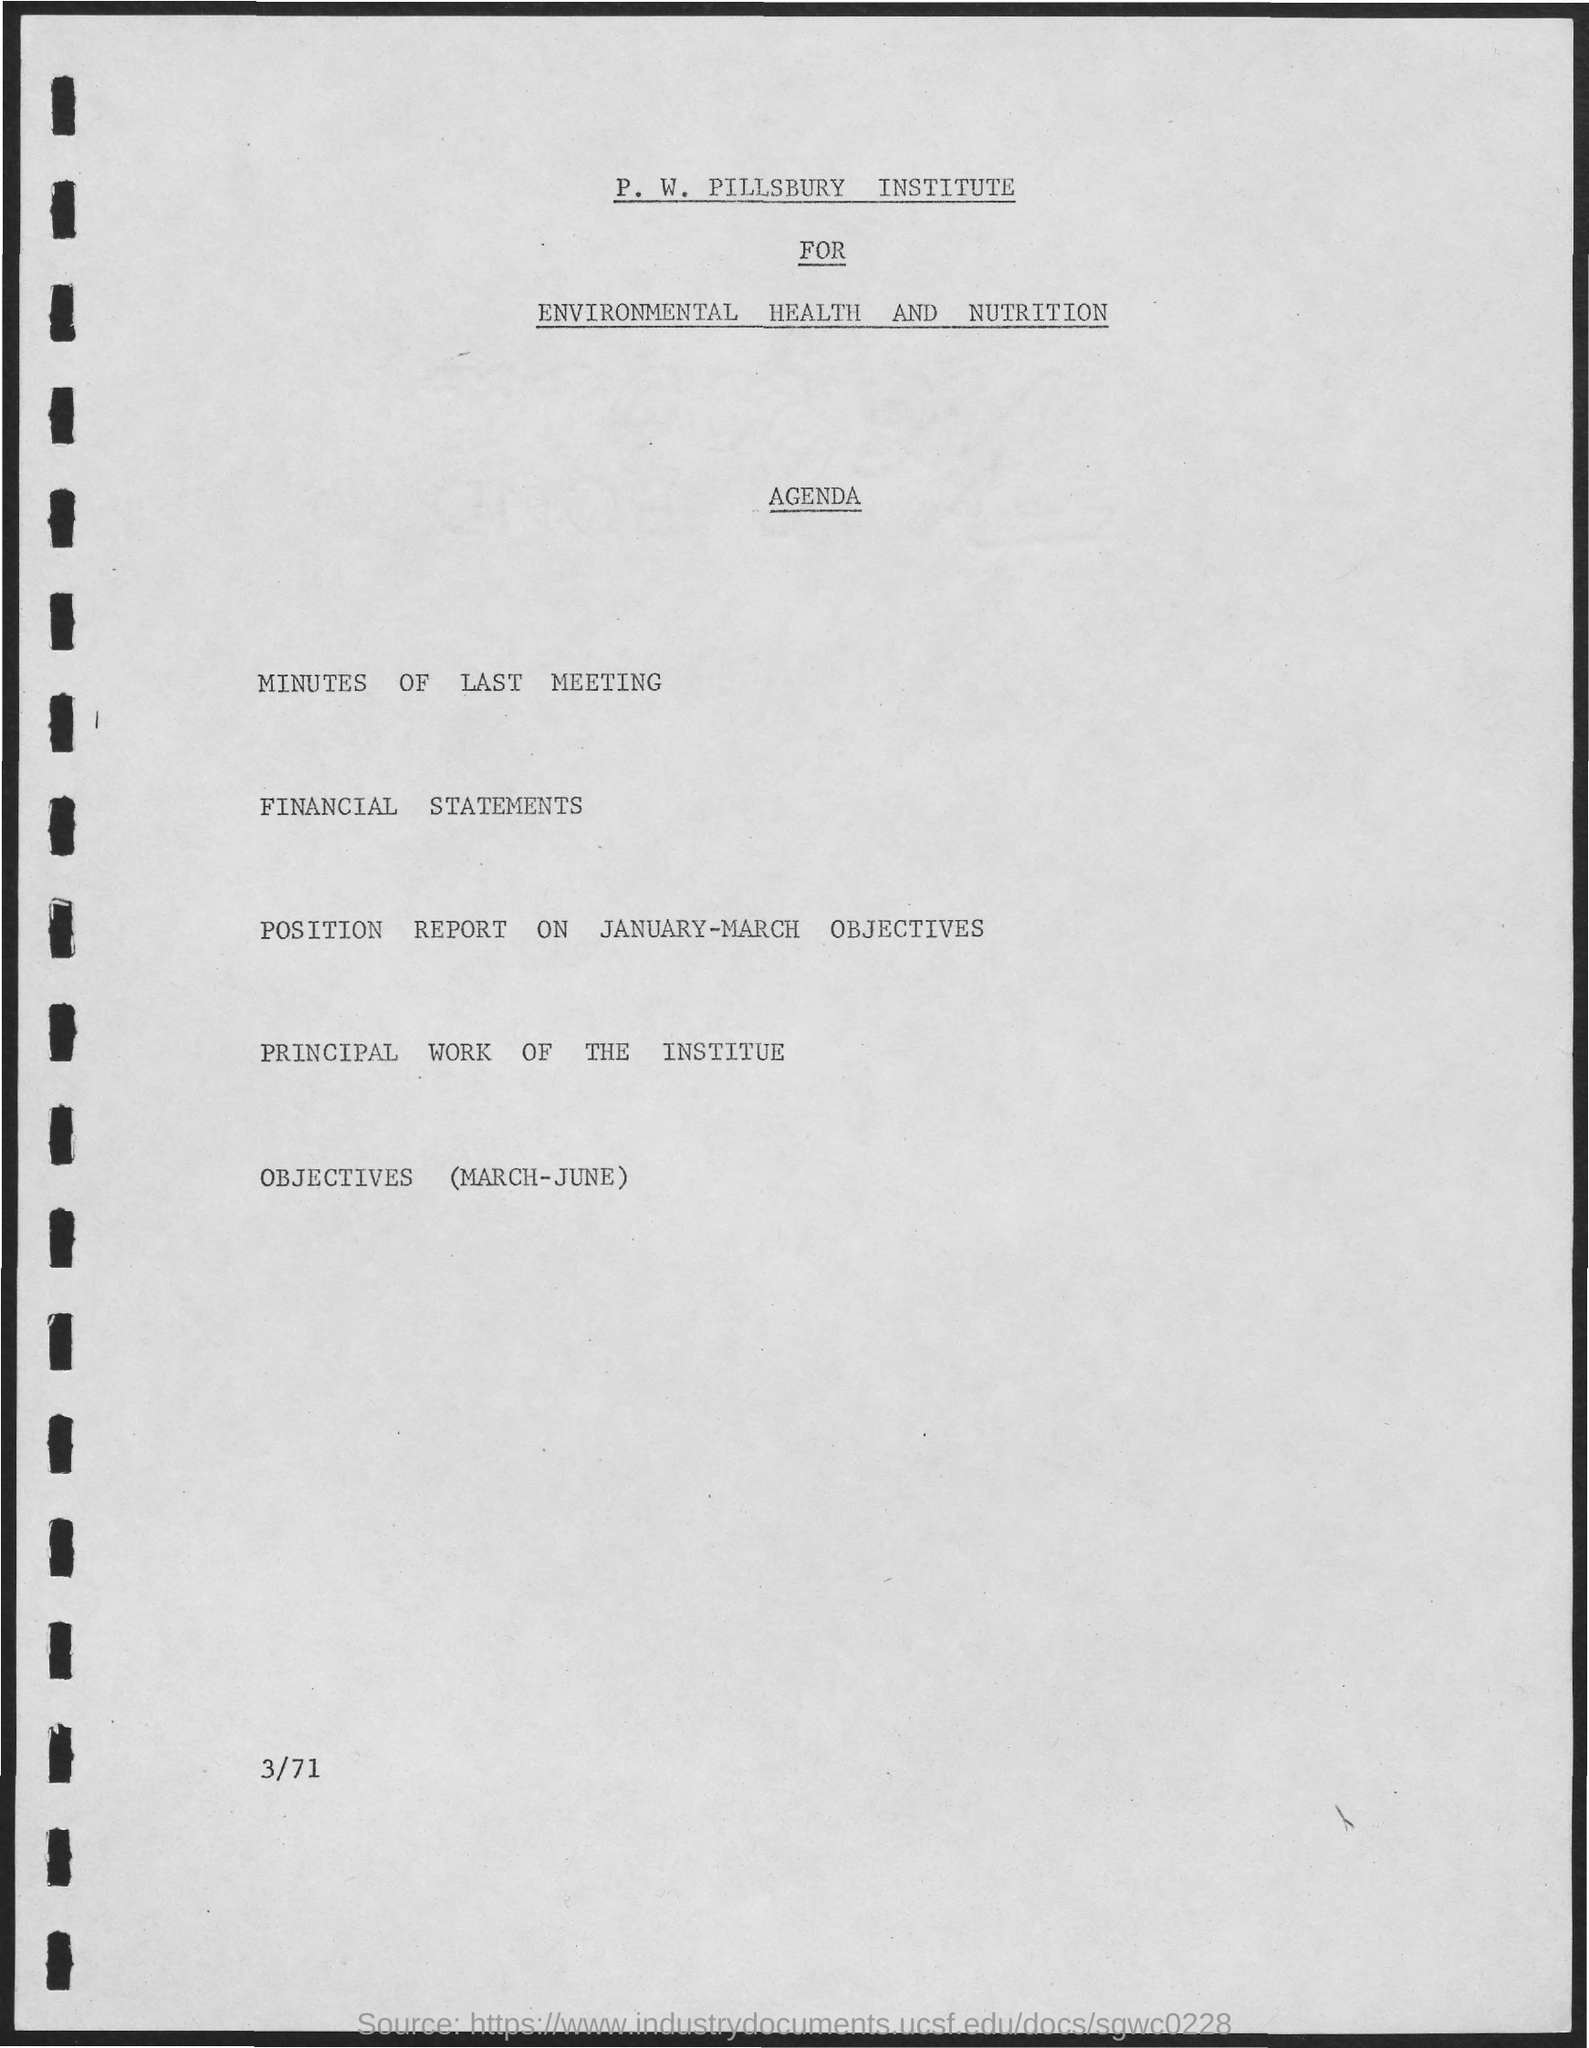What is the first title in the document?
Offer a terse response. P. W. Pillsbury Institute for Environmental Health and Nutrition. What is the second title in the document?
Provide a short and direct response. Agenda. 